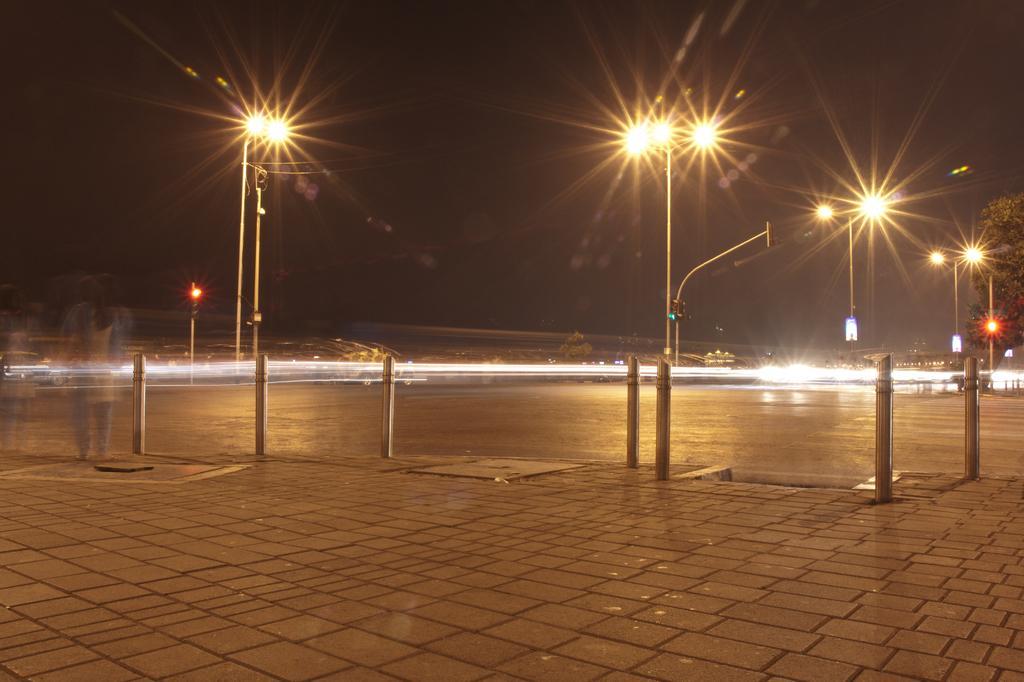Describe this image in one or two sentences. In this image in the center there are some poles and lights, and there are some rods. On the left side of the image there is a reflection of one woman, at the bottom there is a walkway. And in the background there are some poles, traffic signals, trees and buildings. At the top there is sky. 